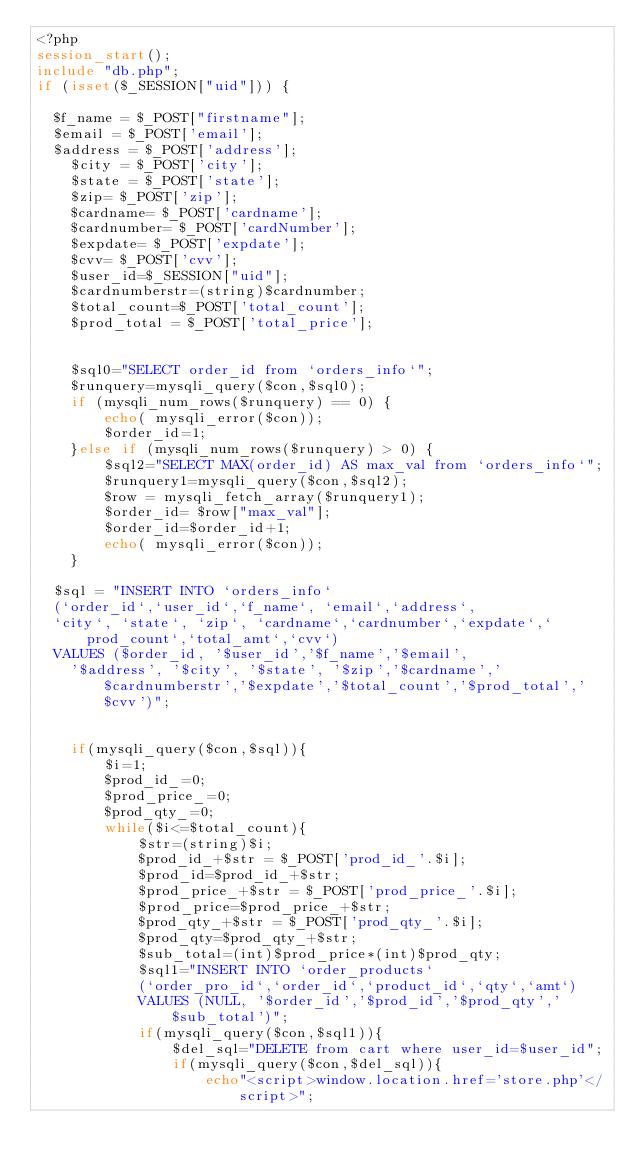<code> <loc_0><loc_0><loc_500><loc_500><_PHP_><?php
session_start();
include "db.php";
if (isset($_SESSION["uid"])) {

	$f_name = $_POST["firstname"];
	$email = $_POST['email'];
	$address = $_POST['address'];
    $city = $_POST['city'];
    $state = $_POST['state'];
    $zip= $_POST['zip'];
    $cardname= $_POST['cardname'];
    $cardnumber= $_POST['cardNumber'];
    $expdate= $_POST['expdate'];
    $cvv= $_POST['cvv'];
    $user_id=$_SESSION["uid"];
    $cardnumberstr=(string)$cardnumber;
    $total_count=$_POST['total_count'];
    $prod_total = $_POST['total_price'];
    
    
    $sql0="SELECT order_id from `orders_info`";
    $runquery=mysqli_query($con,$sql0);
    if (mysqli_num_rows($runquery) == 0) {
        echo( mysqli_error($con));
        $order_id=1;
    }else if (mysqli_num_rows($runquery) > 0) {
        $sql2="SELECT MAX(order_id) AS max_val from `orders_info`";
        $runquery1=mysqli_query($con,$sql2);
        $row = mysqli_fetch_array($runquery1);
        $order_id= $row["max_val"];
        $order_id=$order_id+1;
        echo( mysqli_error($con));
    }

	$sql = "INSERT INTO `orders_info` 
	(`order_id`,`user_id`,`f_name`, `email`,`address`, 
	`city`, `state`, `zip`, `cardname`,`cardnumber`,`expdate`,`prod_count`,`total_amt`,`cvv`) 
	VALUES ($order_id, '$user_id','$f_name','$email', 
    '$address', '$city', '$state', '$zip','$cardname','$cardnumberstr','$expdate','$total_count','$prod_total','$cvv')";


    if(mysqli_query($con,$sql)){
        $i=1;
        $prod_id_=0;
        $prod_price_=0;
        $prod_qty_=0;
        while($i<=$total_count){
            $str=(string)$i;
            $prod_id_+$str = $_POST['prod_id_'.$i];
            $prod_id=$prod_id_+$str;		
            $prod_price_+$str = $_POST['prod_price_'.$i];
            $prod_price=$prod_price_+$str;
            $prod_qty_+$str = $_POST['prod_qty_'.$i];
            $prod_qty=$prod_qty_+$str;
            $sub_total=(int)$prod_price*(int)$prod_qty;
            $sql1="INSERT INTO `order_products` 
            (`order_pro_id`,`order_id`,`product_id`,`qty`,`amt`) 
            VALUES (NULL, '$order_id','$prod_id','$prod_qty','$sub_total')";
            if(mysqli_query($con,$sql1)){
                $del_sql="DELETE from cart where user_id=$user_id";
                if(mysqli_query($con,$del_sql)){
                    echo"<script>window.location.href='store.php'</script>";</code> 